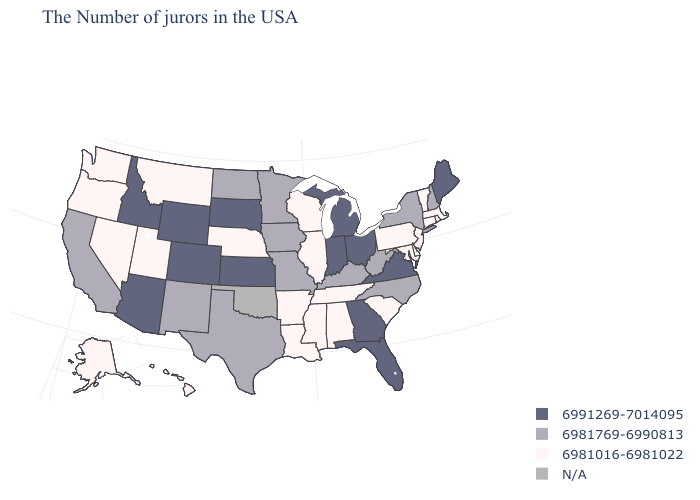Does New Jersey have the lowest value in the USA?
Give a very brief answer. Yes. Name the states that have a value in the range N/A?
Answer briefly. Oklahoma. Which states have the highest value in the USA?
Answer briefly. Maine, Virginia, Ohio, Florida, Georgia, Michigan, Indiana, Kansas, South Dakota, Wyoming, Colorado, Arizona, Idaho. What is the lowest value in the West?
Short answer required. 6981016-6981022. What is the lowest value in states that border Arizona?
Give a very brief answer. 6981016-6981022. Which states have the highest value in the USA?
Short answer required. Maine, Virginia, Ohio, Florida, Georgia, Michigan, Indiana, Kansas, South Dakota, Wyoming, Colorado, Arizona, Idaho. Does Wyoming have the highest value in the USA?
Be succinct. Yes. Does the first symbol in the legend represent the smallest category?
Be succinct. No. What is the lowest value in states that border Washington?
Answer briefly. 6981016-6981022. What is the value of Kentucky?
Concise answer only. 6981769-6990813. Does Alabama have the highest value in the South?
Be succinct. No. Name the states that have a value in the range N/A?
Be succinct. Oklahoma. What is the lowest value in states that border Wisconsin?
Concise answer only. 6981016-6981022. What is the lowest value in the USA?
Give a very brief answer. 6981016-6981022. 